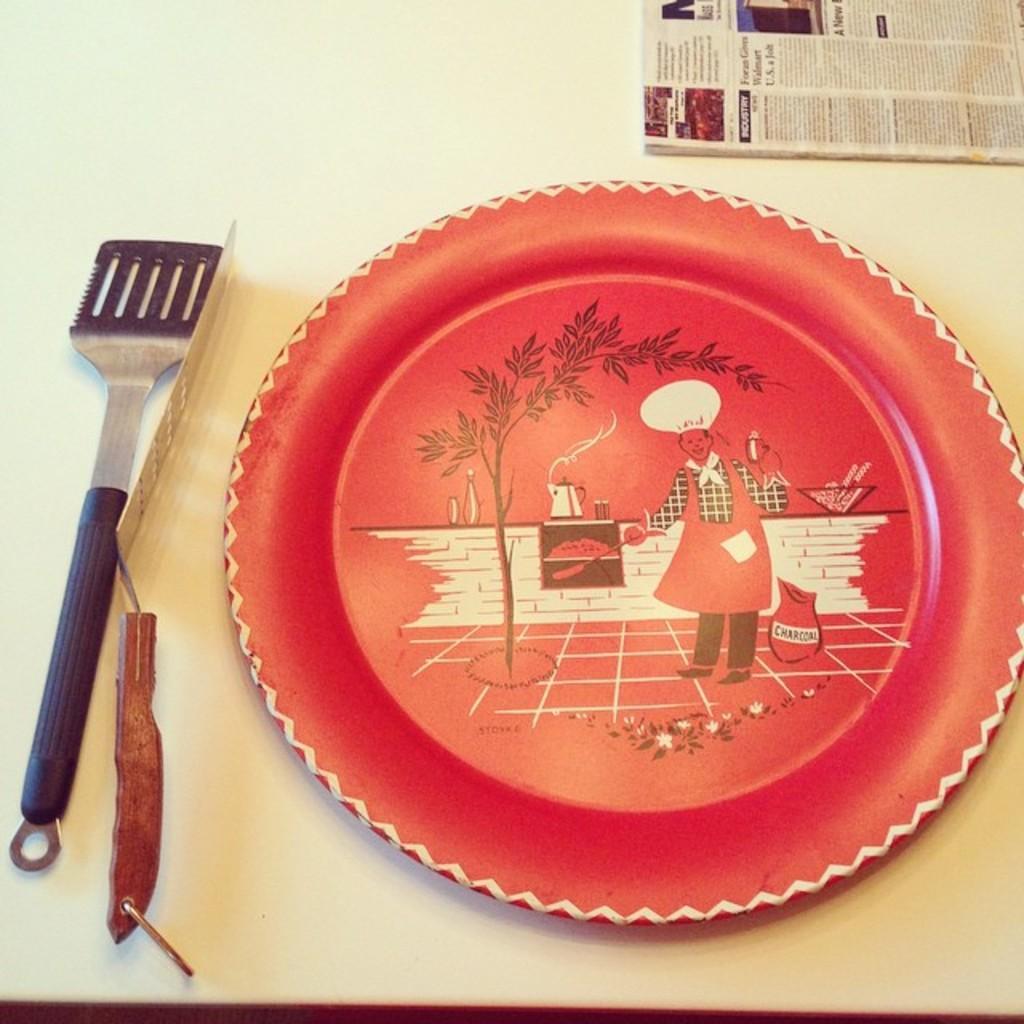Describe this image in one or two sentences. Here we can see plate,knife,spoon and paper on the table. 